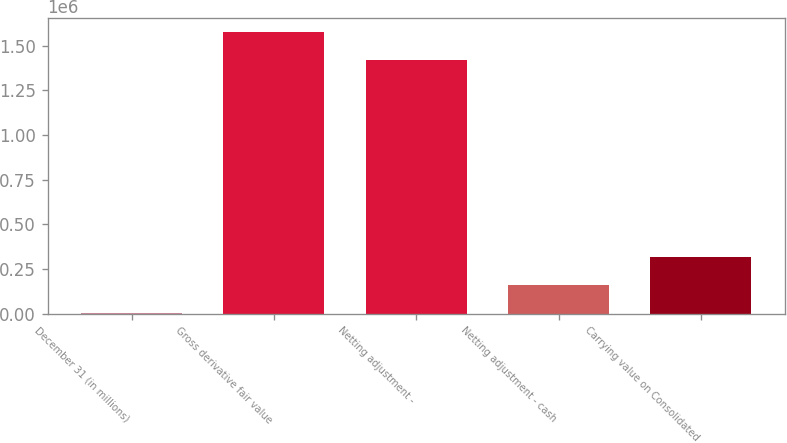<chart> <loc_0><loc_0><loc_500><loc_500><bar_chart><fcel>December 31 (in millions)<fcel>Gross derivative fair value<fcel>Netting adjustment -<fcel>Netting adjustment - cash<fcel>Carrying value on Consolidated<nl><fcel>2009<fcel>1.57619e+06<fcel>1.41984e+06<fcel>158360<fcel>314711<nl></chart> 